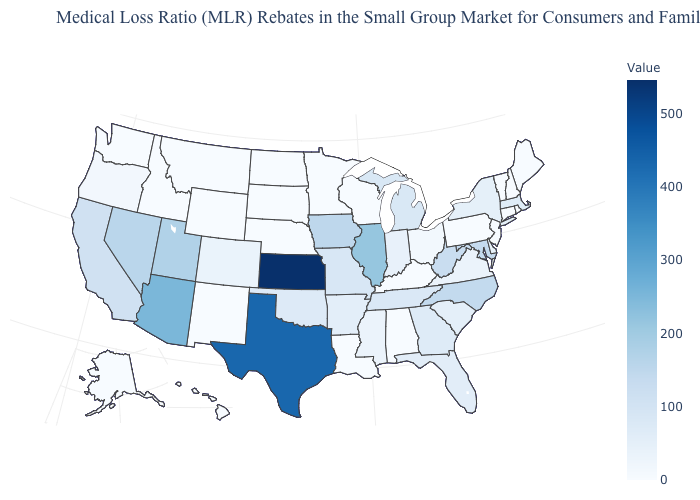Among the states that border Missouri , which have the highest value?
Be succinct. Kansas. Does Kansas have the highest value in the USA?
Keep it brief. Yes. Among the states that border North Dakota , which have the highest value?
Concise answer only. Minnesota, Montana, South Dakota. Does the map have missing data?
Write a very short answer. No. Which states have the highest value in the USA?
Quick response, please. Kansas. 